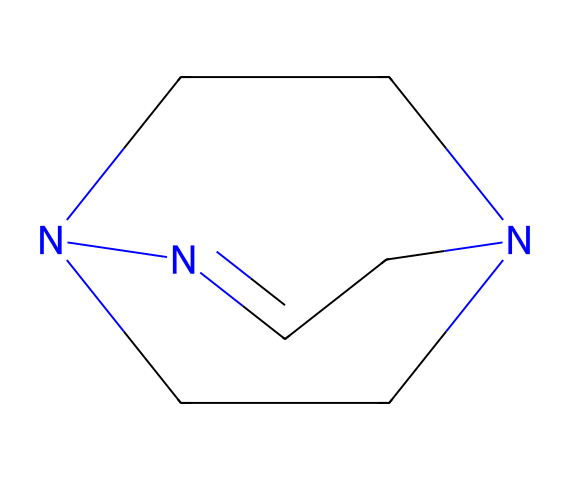What is the name of this chemical? The SMILES representation corresponds to the chemical structure known as 1,5,7-triazabicyclo[4.4.0]dec-5-ene. This name comes from the arrangement of the nitrogen atoms (triazabicyclo) and the specific cyclic structure it forms.
Answer: 1,5,7-triazabicyclo[4.4.0]dec-5-ene How many nitrogen atoms are present in this molecule? By analyzing the SMILES representation, you can identify three nitrogen atoms in the structure, associated with the 'N' letters in the SMILES code.
Answer: 3 What type of chemical structure does this molecule have? The molecule has a bicyclic structure, as indicated by the term "bicyclo" in its name, which suggests that it includes two interconnected rings comprising multiple atoms.
Answer: bicyclic What is the molecular formula of this compound? The molecular formula can be derived by counting the number of each type of atom in the molecule based on the structure represented in the SMILES. There are 8 carbon atoms, 12 hydrogen atoms, and 3 nitrogen atoms, which gives the formula C8H12N4.
Answer: C8H12N4 What type of reactions is this compound commonly used for? This compound is classified as a superbase and is often used in rapid-curing resin applications, indicating its utility in facilitating quick chemical reactions.
Answer: rapid-curing resins How does the presence of nitrogen influence the basicity of the compound? The nitrogen atoms in this compound contribute to its basicity due to the availability of lone pairs that can accept protons, characterizing it as a strong base or superbase.
Answer: increases basicity What role does the bicyclic structure play in the properties of this superbase? The bicyclic structure enhances the stability of the superbase, allowing for effective proton abstraction and making it more reactive in its role as a superbase compared to simpler structures.
Answer: enhances stability 